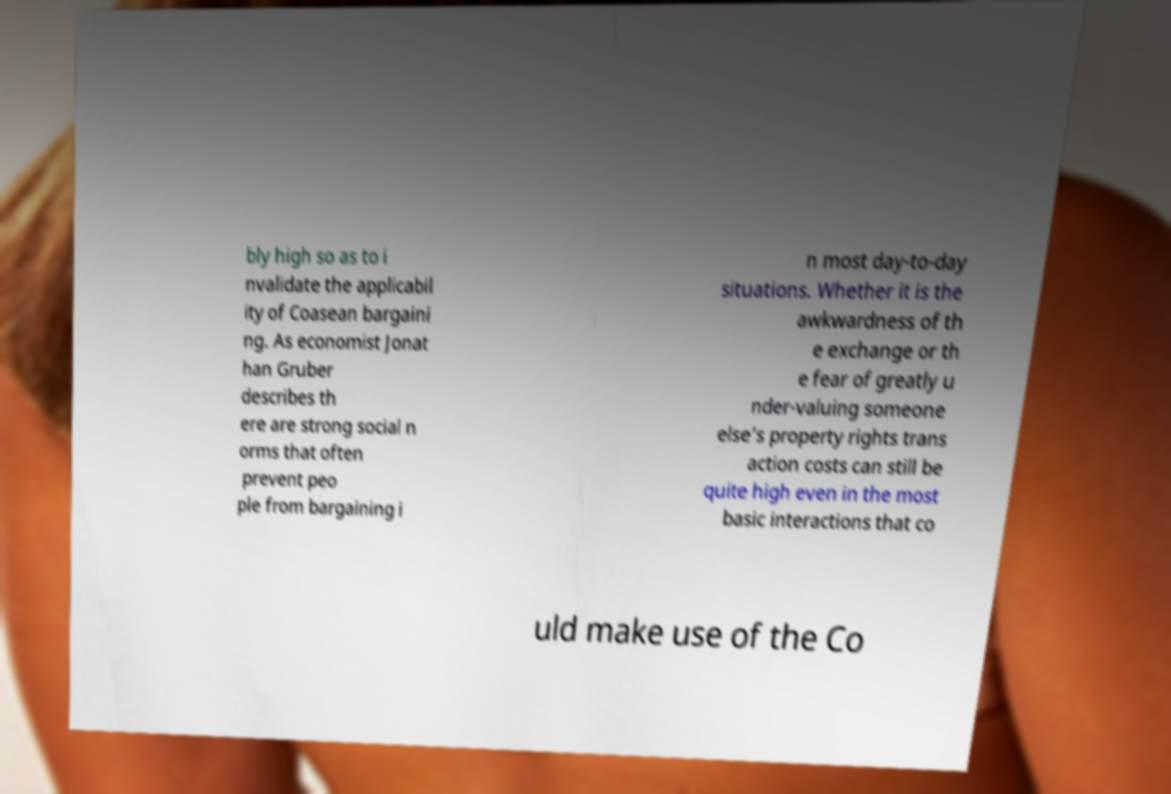Please identify and transcribe the text found in this image. bly high so as to i nvalidate the applicabil ity of Coasean bargaini ng. As economist Jonat han Gruber describes th ere are strong social n orms that often prevent peo ple from bargaining i n most day-to-day situations. Whether it is the awkwardness of th e exchange or th e fear of greatly u nder-valuing someone else’s property rights trans action costs can still be quite high even in the most basic interactions that co uld make use of the Co 